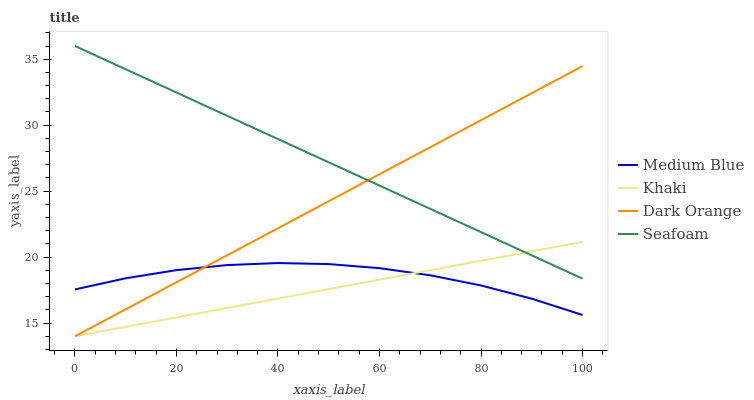Does Medium Blue have the minimum area under the curve?
Answer yes or no. No. Does Medium Blue have the maximum area under the curve?
Answer yes or no. No. Is Medium Blue the smoothest?
Answer yes or no. No. Is Khaki the roughest?
Answer yes or no. No. Does Medium Blue have the lowest value?
Answer yes or no. No. Does Khaki have the highest value?
Answer yes or no. No. Is Medium Blue less than Seafoam?
Answer yes or no. Yes. Is Seafoam greater than Medium Blue?
Answer yes or no. Yes. Does Medium Blue intersect Seafoam?
Answer yes or no. No. 